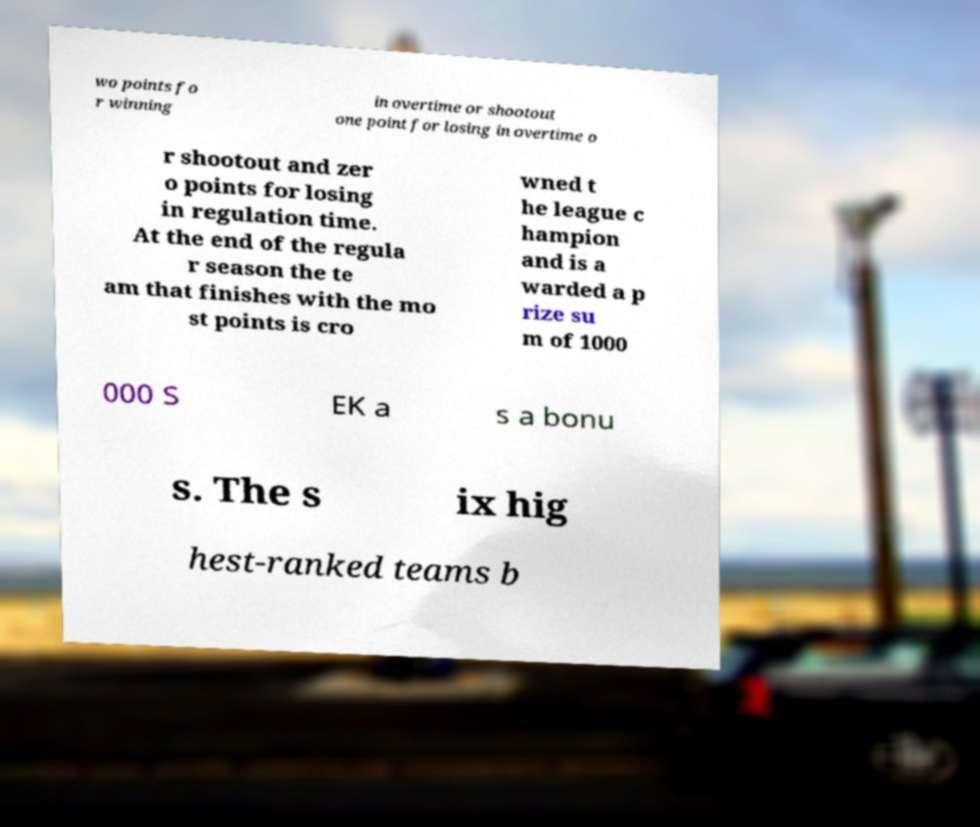There's text embedded in this image that I need extracted. Can you transcribe it verbatim? wo points fo r winning in overtime or shootout one point for losing in overtime o r shootout and zer o points for losing in regulation time. At the end of the regula r season the te am that finishes with the mo st points is cro wned t he league c hampion and is a warded a p rize su m of 1000 000 S EK a s a bonu s. The s ix hig hest-ranked teams b 